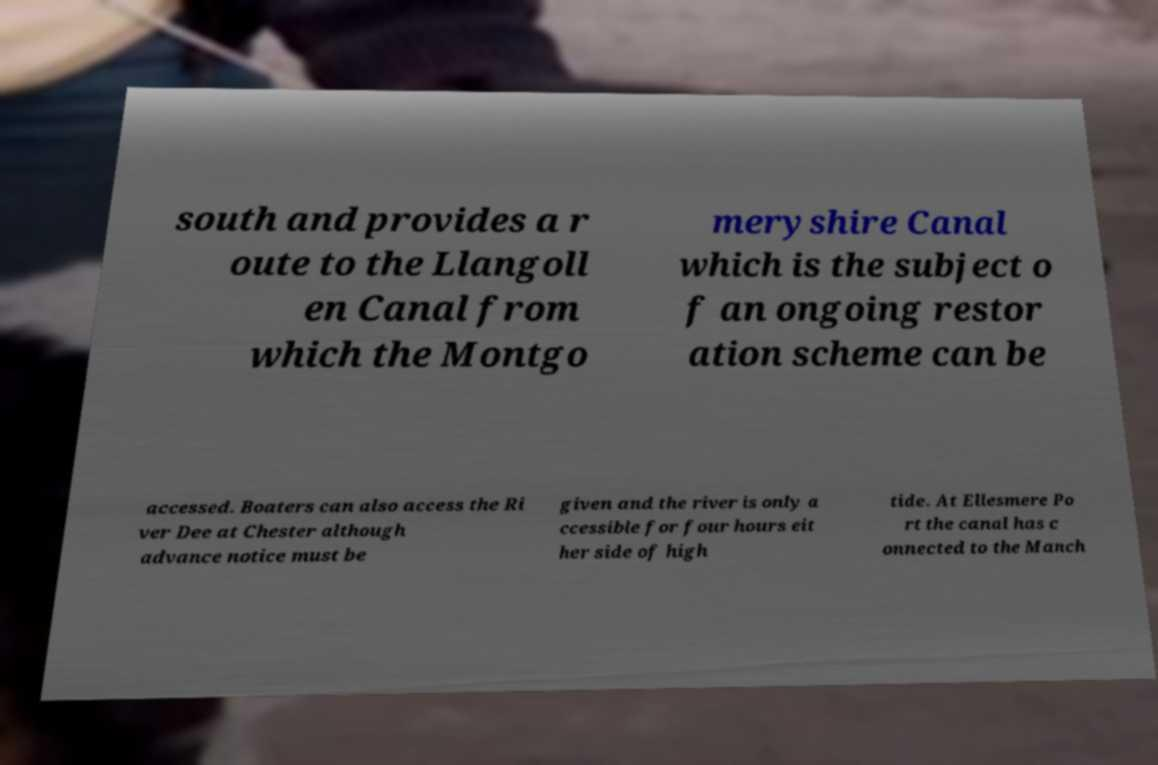Please identify and transcribe the text found in this image. south and provides a r oute to the Llangoll en Canal from which the Montgo meryshire Canal which is the subject o f an ongoing restor ation scheme can be accessed. Boaters can also access the Ri ver Dee at Chester although advance notice must be given and the river is only a ccessible for four hours eit her side of high tide. At Ellesmere Po rt the canal has c onnected to the Manch 